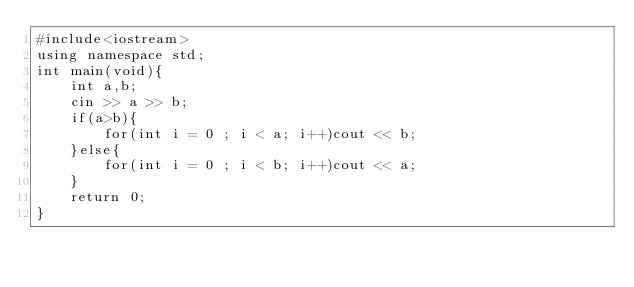Convert code to text. <code><loc_0><loc_0><loc_500><loc_500><_C++_>#include<iostream>
using namespace std;
int main(void){
    int a,b;
    cin >> a >> b;
    if(a>b){
        for(int i = 0 ; i < a; i++)cout << b;
    }else{
        for(int i = 0 ; i < b; i++)cout << a;
    }
    return 0;
}</code> 